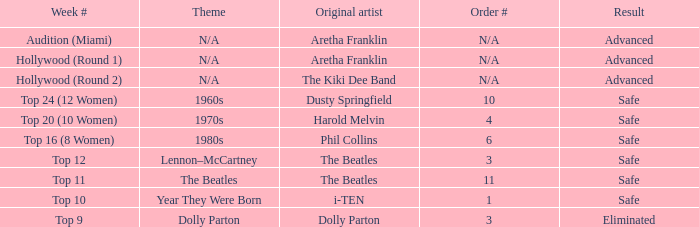What is the week number that has Dolly Parton as the theme? Top 9. 